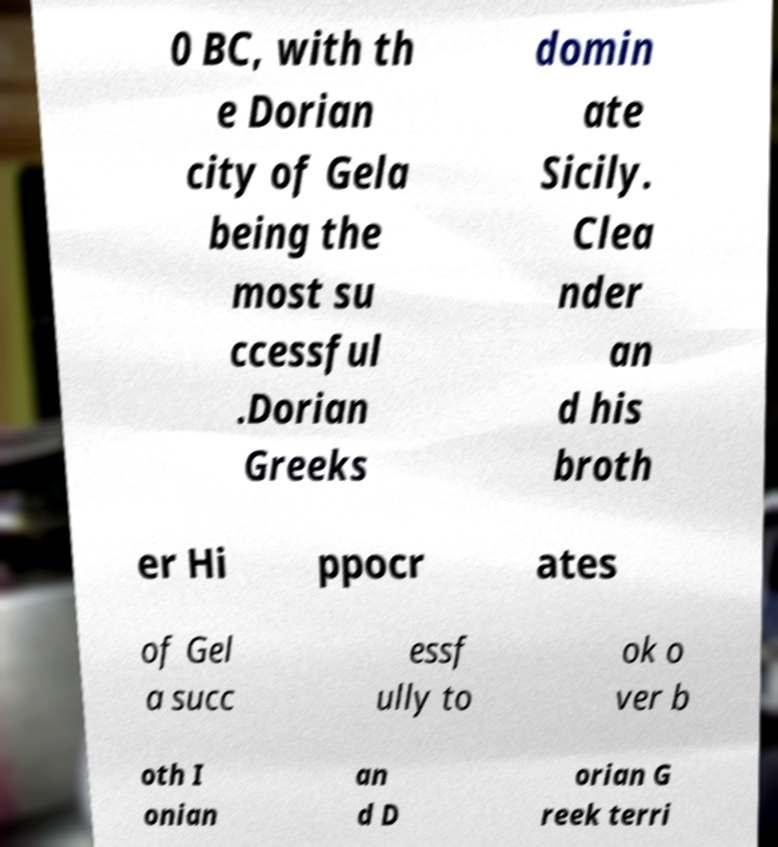Please identify and transcribe the text found in this image. 0 BC, with th e Dorian city of Gela being the most su ccessful .Dorian Greeks domin ate Sicily. Clea nder an d his broth er Hi ppocr ates of Gel a succ essf ully to ok o ver b oth I onian an d D orian G reek terri 